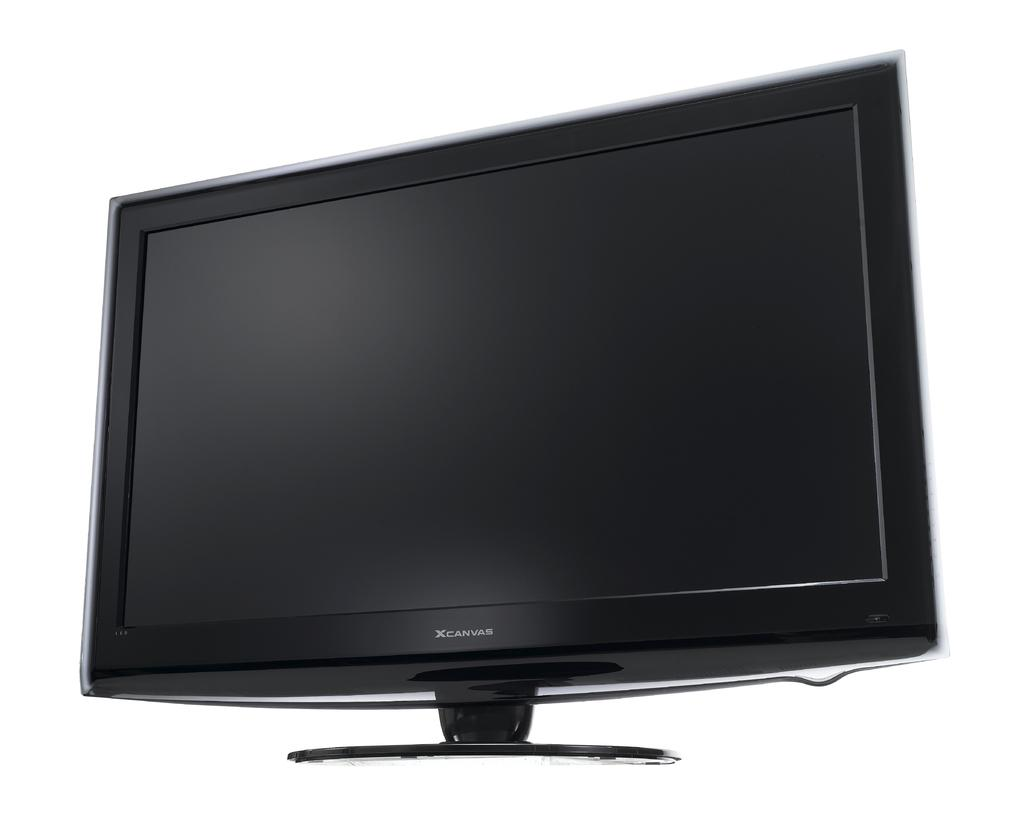<image>
Create a compact narrative representing the image presented. The black television pictured is made by the company XCanvas. 